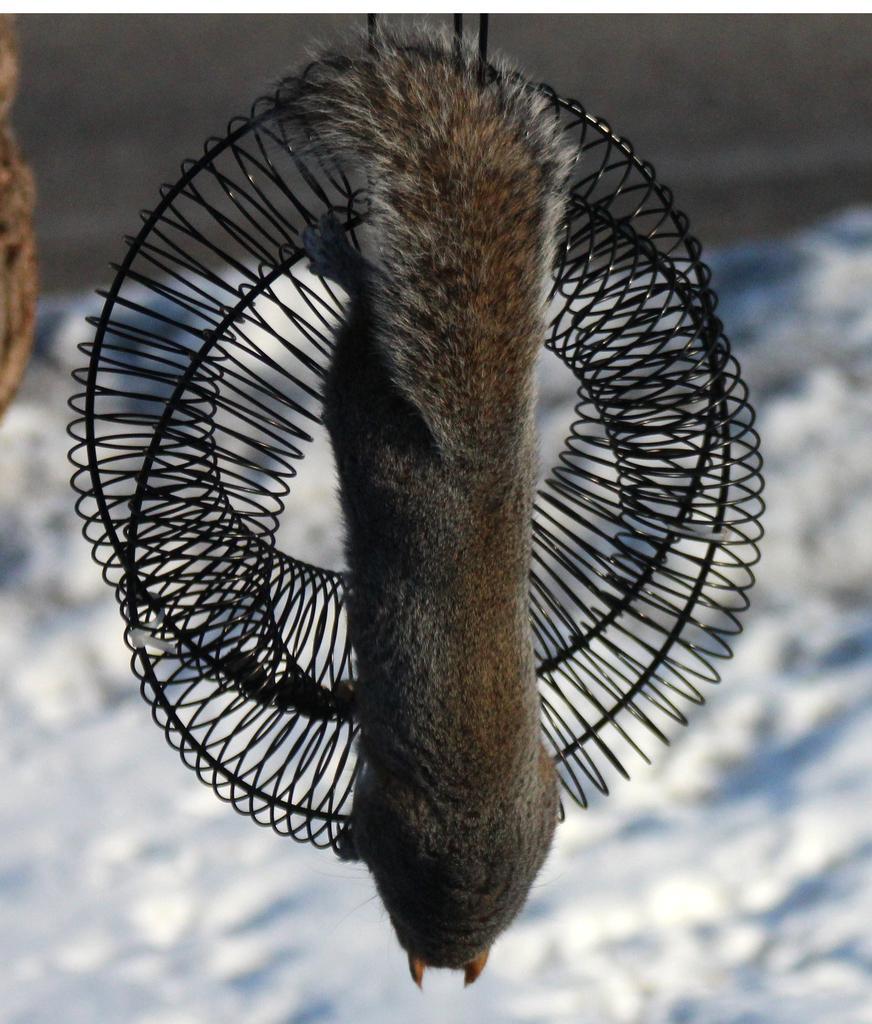How would you summarize this image in a sentence or two? In the center of the image we can see one round spring type object. On that object, we can see one animal, which is in brown and ash color. On the left side of the image, we can see one object. In the background we can see a few other objects. 